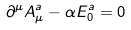Convert formula to latex. <formula><loc_0><loc_0><loc_500><loc_500>\partial ^ { \mu } A _ { \mu } ^ { a } - \alpha E _ { 0 } ^ { a } = 0</formula> 